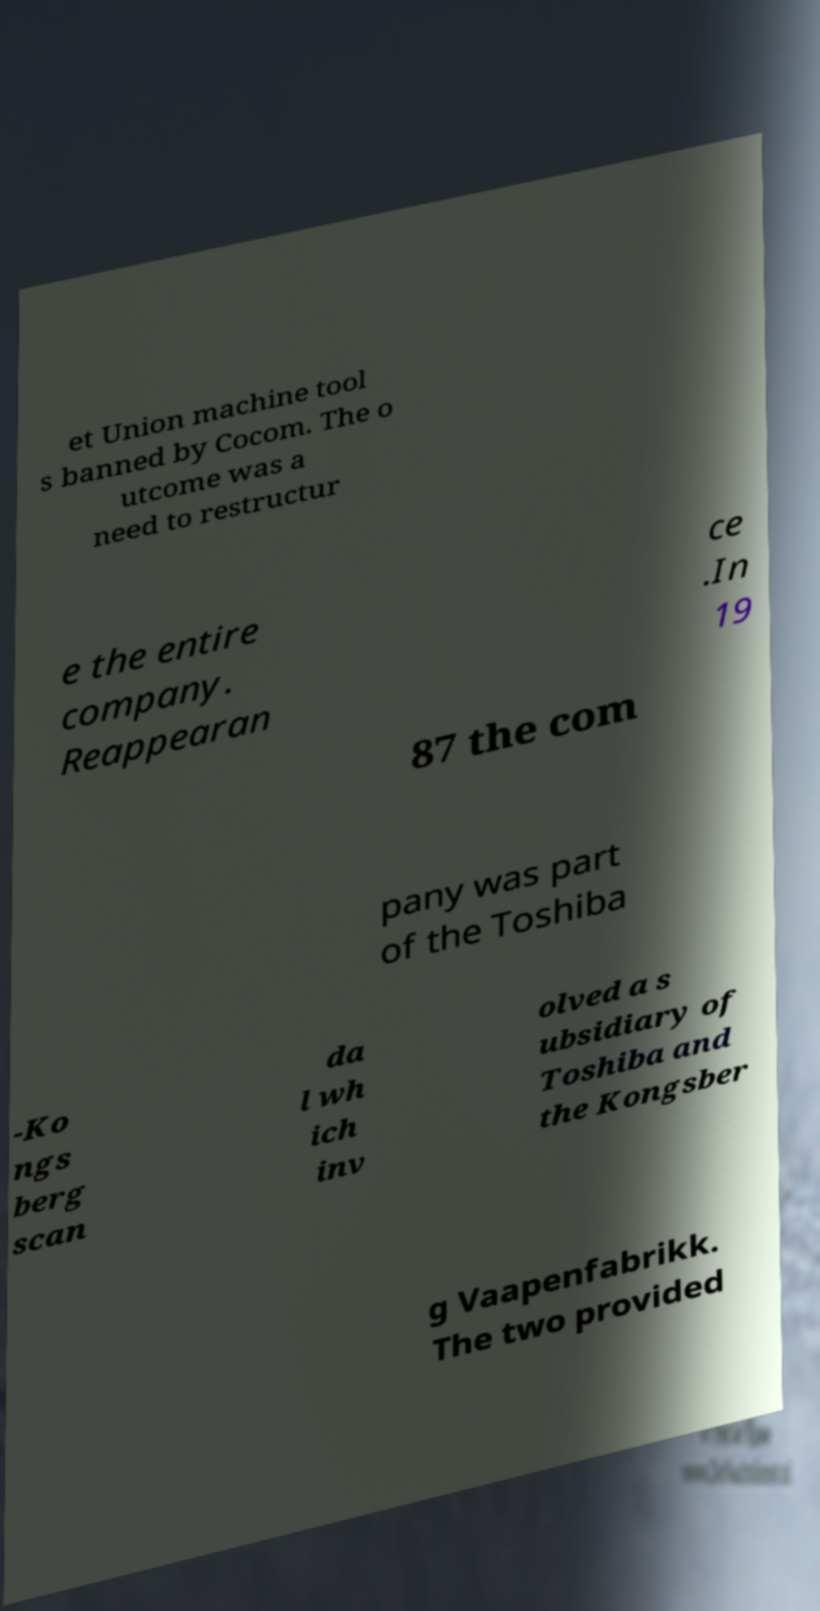Can you accurately transcribe the text from the provided image for me? et Union machine tool s banned by Cocom. The o utcome was a need to restructur e the entire company. Reappearan ce .In 19 87 the com pany was part of the Toshiba -Ko ngs berg scan da l wh ich inv olved a s ubsidiary of Toshiba and the Kongsber g Vaapenfabrikk. The two provided 